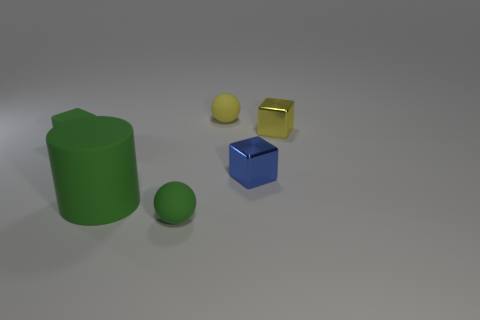Add 2 large green shiny spheres. How many objects exist? 8 Subtract all cylinders. How many objects are left? 5 Subtract 0 cyan balls. How many objects are left? 6 Subtract all yellow metal objects. Subtract all metal objects. How many objects are left? 3 Add 4 blue metallic objects. How many blue metallic objects are left? 5 Add 5 yellow balls. How many yellow balls exist? 6 